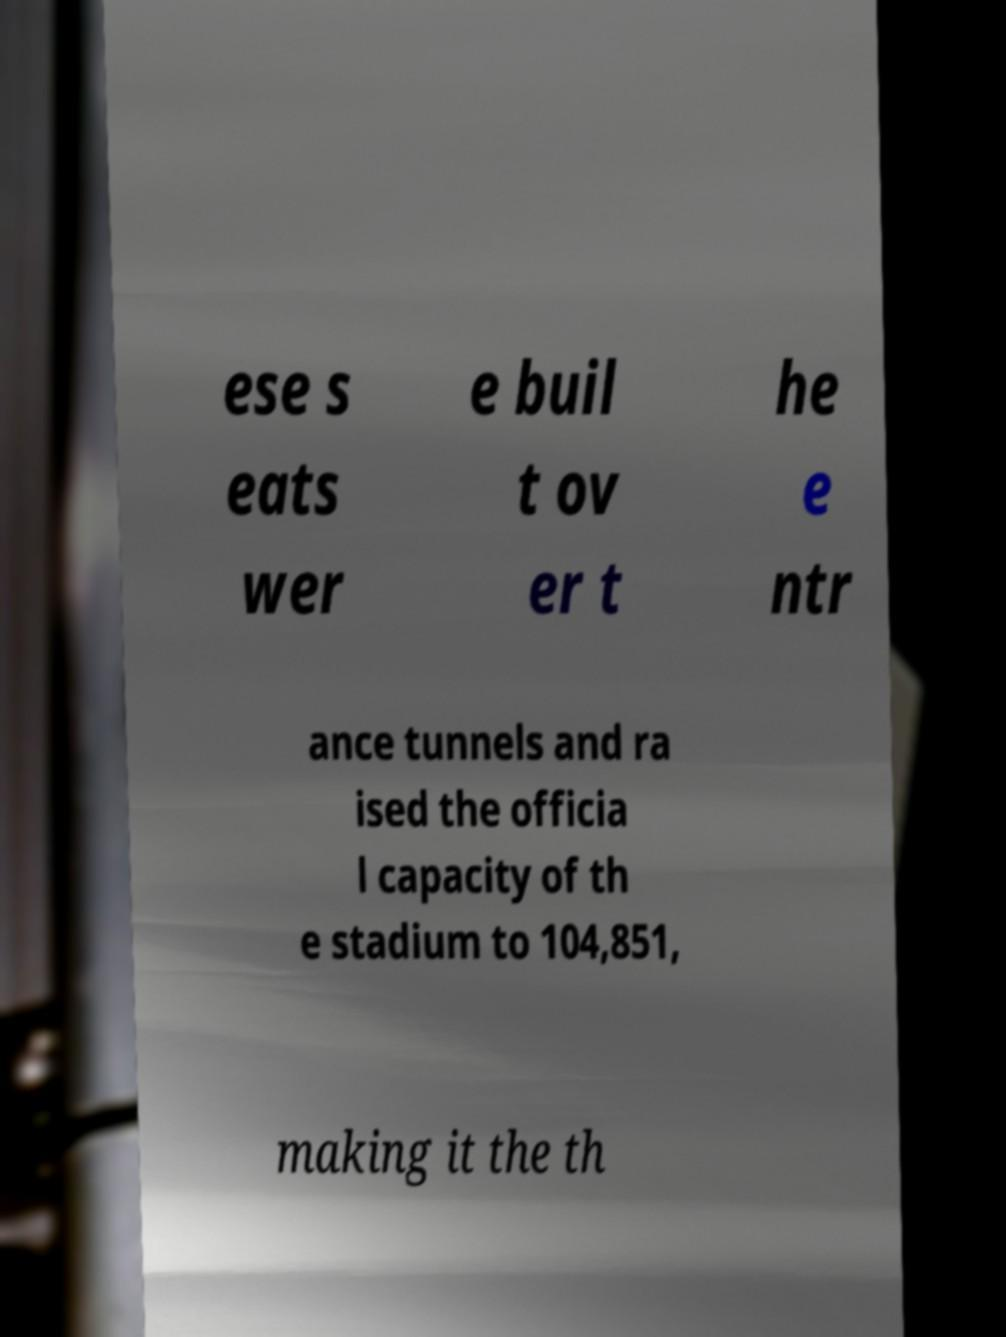Can you accurately transcribe the text from the provided image for me? ese s eats wer e buil t ov er t he e ntr ance tunnels and ra ised the officia l capacity of th e stadium to 104,851, making it the th 